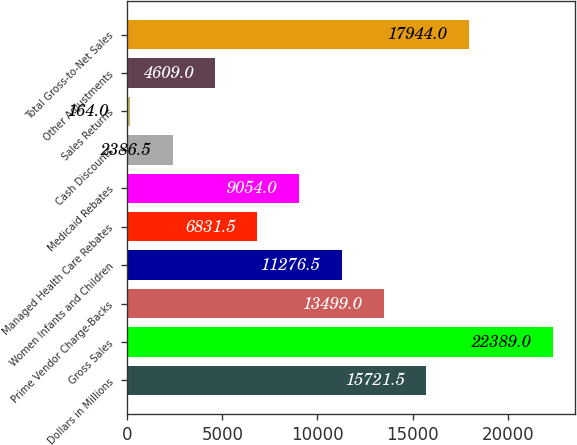Convert chart. <chart><loc_0><loc_0><loc_500><loc_500><bar_chart><fcel>Dollars in Millions<fcel>Gross Sales<fcel>Prime Vendor Charge-Backs<fcel>Women Infants and Children<fcel>Managed Health Care Rebates<fcel>Medicaid Rebates<fcel>Cash Discounts<fcel>Sales Returns<fcel>Other Adjustments<fcel>Total Gross-to-Net Sales<nl><fcel>15721.5<fcel>22389<fcel>13499<fcel>11276.5<fcel>6831.5<fcel>9054<fcel>2386.5<fcel>164<fcel>4609<fcel>17944<nl></chart> 